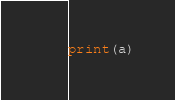<code> <loc_0><loc_0><loc_500><loc_500><_Python_>print(a)</code> 